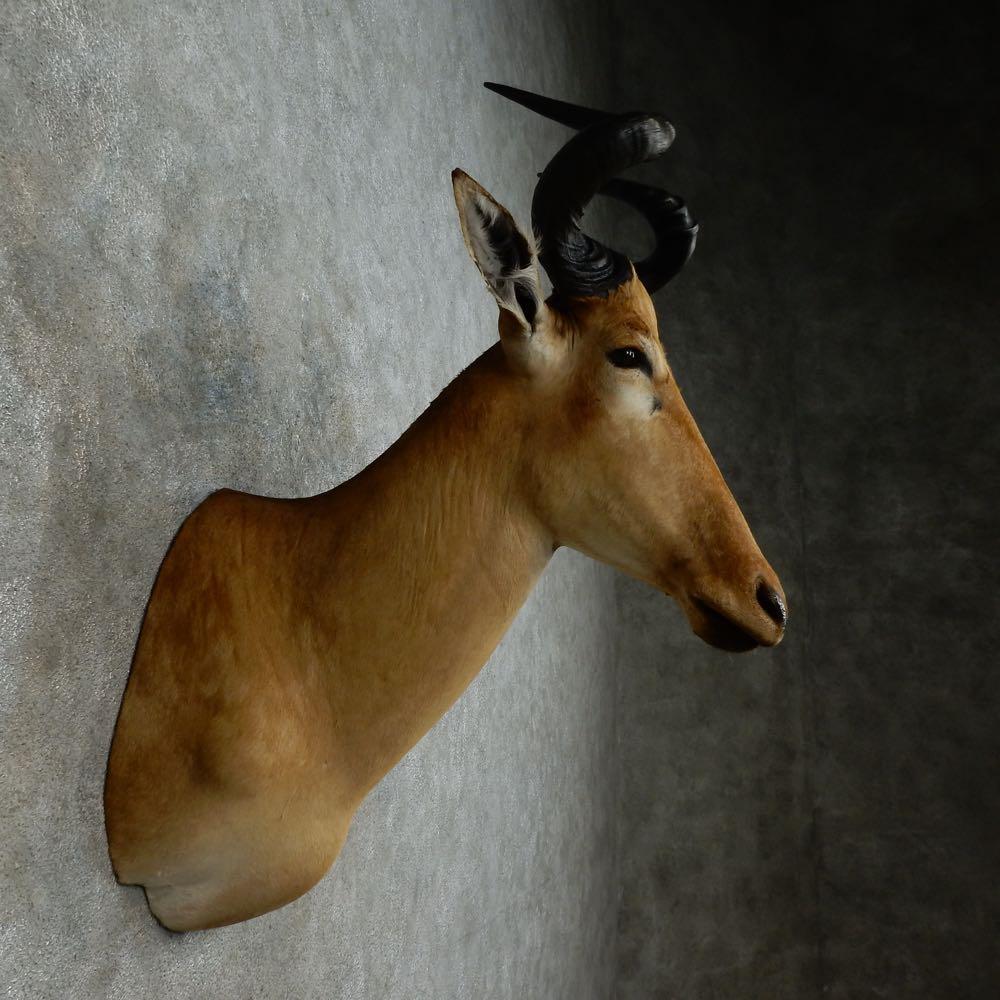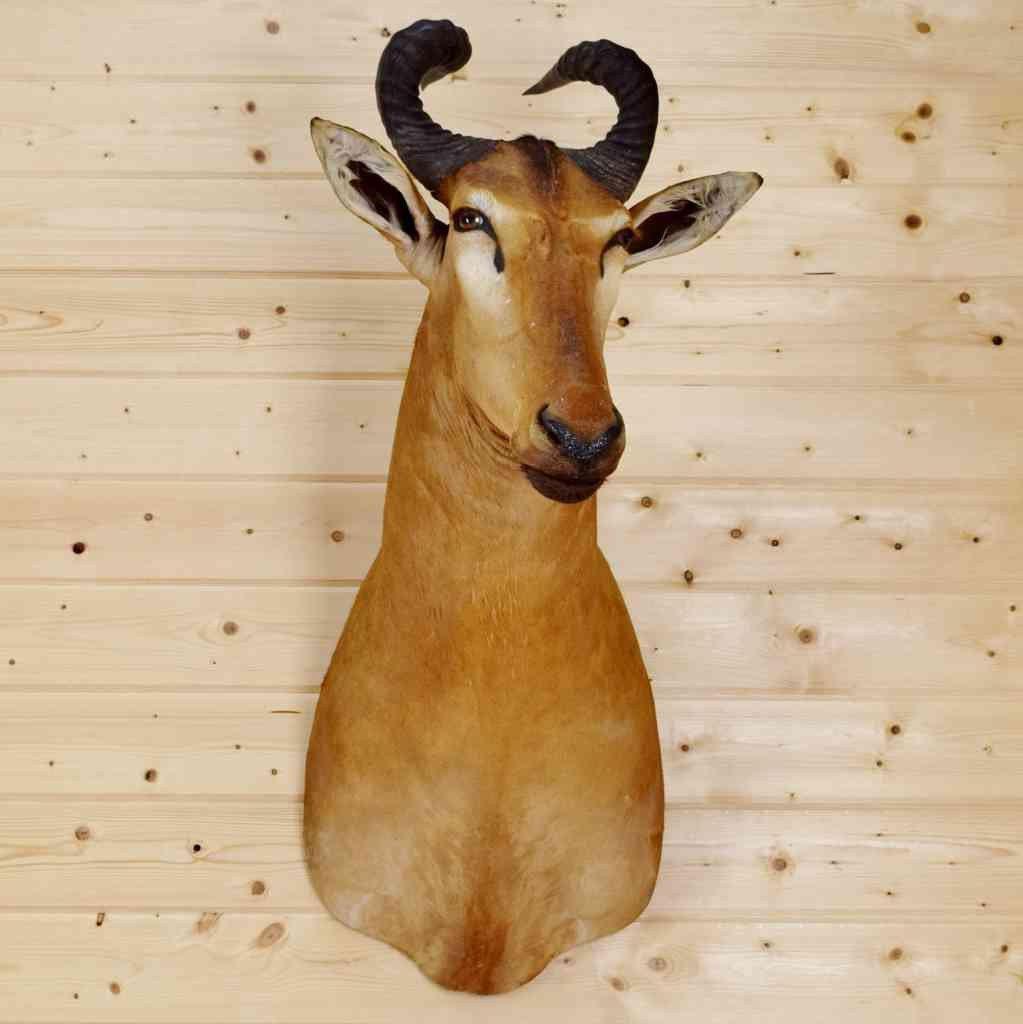The first image is the image on the left, the second image is the image on the right. Considering the images on both sides, is "An image shows the head of a horned animal mounted on a knotty wood plank wall." valid? Answer yes or no. Yes. The first image is the image on the left, the second image is the image on the right. Given the left and right images, does the statement "There are two antelope heads shown without a body." hold true? Answer yes or no. Yes. 